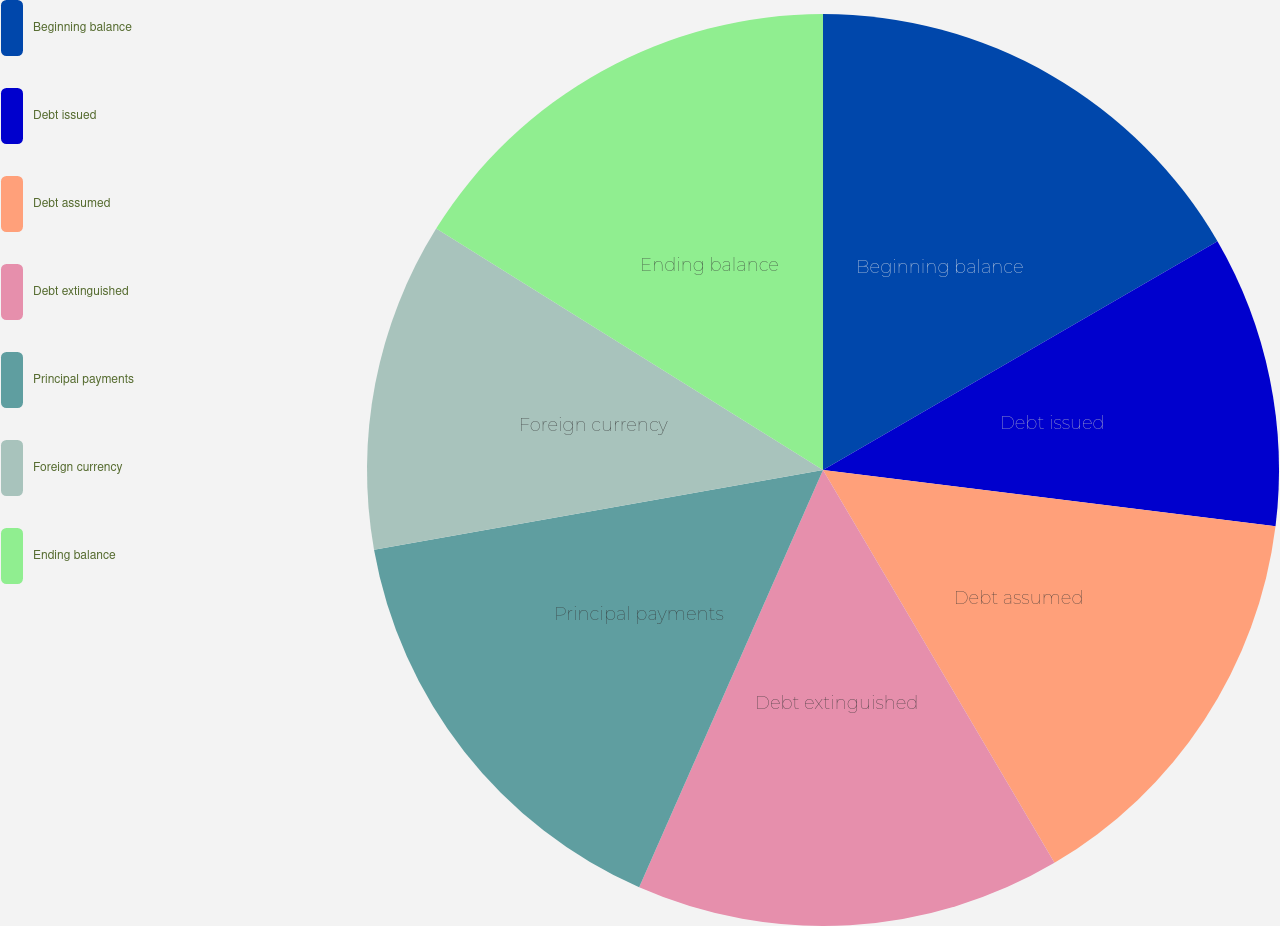<chart> <loc_0><loc_0><loc_500><loc_500><pie_chart><fcel>Beginning balance<fcel>Debt issued<fcel>Debt assumed<fcel>Debt extinguished<fcel>Principal payments<fcel>Foreign currency<fcel>Ending balance<nl><fcel>16.64%<fcel>10.33%<fcel>14.56%<fcel>15.08%<fcel>15.6%<fcel>11.68%<fcel>16.12%<nl></chart> 